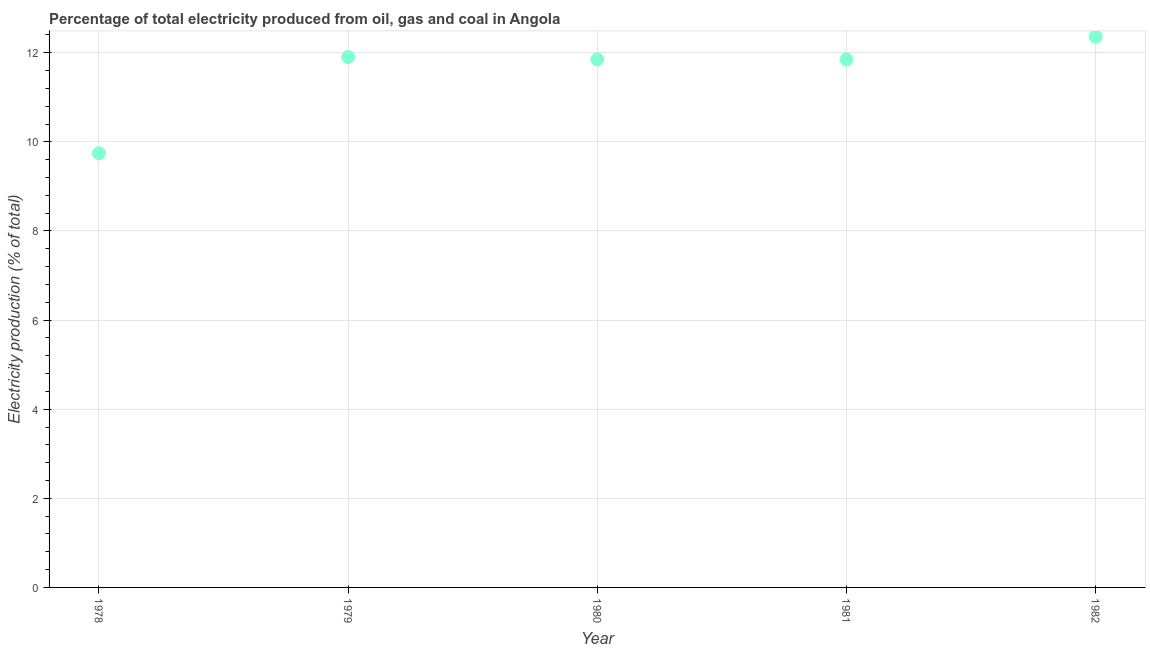What is the electricity production in 1978?
Ensure brevity in your answer.  9.74. Across all years, what is the maximum electricity production?
Make the answer very short. 12.36. Across all years, what is the minimum electricity production?
Give a very brief answer. 9.74. In which year was the electricity production maximum?
Make the answer very short. 1982. In which year was the electricity production minimum?
Your answer should be compact. 1978. What is the sum of the electricity production?
Provide a short and direct response. 57.71. What is the difference between the electricity production in 1979 and 1981?
Your answer should be very brief. 0.05. What is the average electricity production per year?
Keep it short and to the point. 11.54. What is the median electricity production?
Provide a short and direct response. 11.85. In how many years, is the electricity production greater than 10.4 %?
Provide a short and direct response. 4. Do a majority of the years between 1978 and 1979 (inclusive) have electricity production greater than 1.2000000000000002 %?
Provide a short and direct response. Yes. What is the ratio of the electricity production in 1981 to that in 1982?
Make the answer very short. 0.96. What is the difference between the highest and the second highest electricity production?
Offer a very short reply. 0.46. Is the sum of the electricity production in 1978 and 1980 greater than the maximum electricity production across all years?
Provide a short and direct response. Yes. What is the difference between the highest and the lowest electricity production?
Your answer should be very brief. 2.62. In how many years, is the electricity production greater than the average electricity production taken over all years?
Offer a terse response. 4. How many dotlines are there?
Your response must be concise. 1. Are the values on the major ticks of Y-axis written in scientific E-notation?
Offer a terse response. No. Does the graph contain any zero values?
Your answer should be very brief. No. Does the graph contain grids?
Keep it short and to the point. Yes. What is the title of the graph?
Give a very brief answer. Percentage of total electricity produced from oil, gas and coal in Angola. What is the label or title of the X-axis?
Provide a succinct answer. Year. What is the label or title of the Y-axis?
Offer a terse response. Electricity production (% of total). What is the Electricity production (% of total) in 1978?
Your response must be concise. 9.74. What is the Electricity production (% of total) in 1979?
Make the answer very short. 11.9. What is the Electricity production (% of total) in 1980?
Your answer should be compact. 11.85. What is the Electricity production (% of total) in 1981?
Give a very brief answer. 11.85. What is the Electricity production (% of total) in 1982?
Make the answer very short. 12.36. What is the difference between the Electricity production (% of total) in 1978 and 1979?
Your response must be concise. -2.16. What is the difference between the Electricity production (% of total) in 1978 and 1980?
Keep it short and to the point. -2.11. What is the difference between the Electricity production (% of total) in 1978 and 1981?
Your response must be concise. -2.11. What is the difference between the Electricity production (% of total) in 1978 and 1982?
Your answer should be compact. -2.62. What is the difference between the Electricity production (% of total) in 1979 and 1980?
Ensure brevity in your answer.  0.05. What is the difference between the Electricity production (% of total) in 1979 and 1981?
Provide a succinct answer. 0.05. What is the difference between the Electricity production (% of total) in 1979 and 1982?
Provide a succinct answer. -0.46. What is the difference between the Electricity production (% of total) in 1980 and 1982?
Your answer should be very brief. -0.51. What is the difference between the Electricity production (% of total) in 1981 and 1982?
Provide a short and direct response. -0.51. What is the ratio of the Electricity production (% of total) in 1978 to that in 1979?
Provide a succinct answer. 0.82. What is the ratio of the Electricity production (% of total) in 1978 to that in 1980?
Provide a succinct answer. 0.82. What is the ratio of the Electricity production (% of total) in 1978 to that in 1981?
Offer a terse response. 0.82. What is the ratio of the Electricity production (% of total) in 1978 to that in 1982?
Your answer should be compact. 0.79. What is the ratio of the Electricity production (% of total) in 1979 to that in 1980?
Provide a succinct answer. 1. 